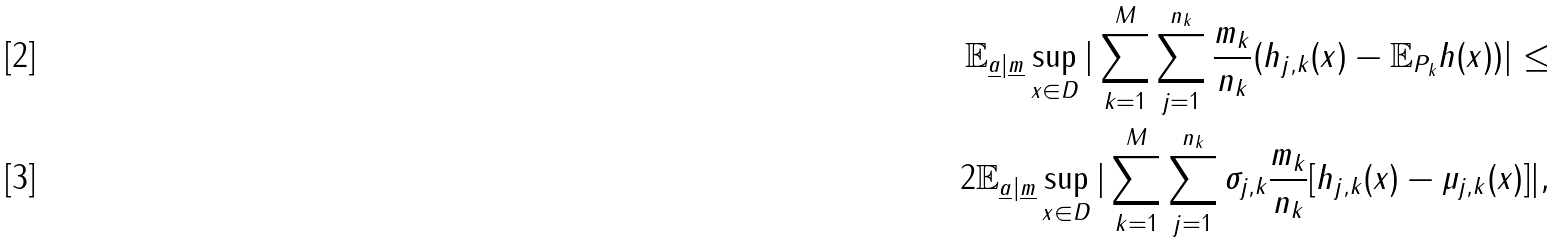Convert formula to latex. <formula><loc_0><loc_0><loc_500><loc_500>\mathbb { E } _ { \underline { a } | \underline { m } } \sup _ { x \in D } | \sum _ { k = 1 } ^ { M } \sum _ { j = 1 } ^ { n _ { k } } \frac { m _ { k } } { n _ { k } } ( h _ { j , k } ( x ) - \mathbb { E } _ { P _ { k } } h ( x ) ) | \leq & \\ 2 \mathbb { E } _ { \underline { a } | \underline { m } } \sup _ { x \in D } | \sum _ { k = 1 } ^ { M } \sum _ { j = 1 } ^ { n _ { k } } \sigma _ { j , k } \frac { m _ { k } } { n _ { k } } [ h _ { j , k } ( x ) - \mu _ { j , k } ( x ) ] | ,</formula> 